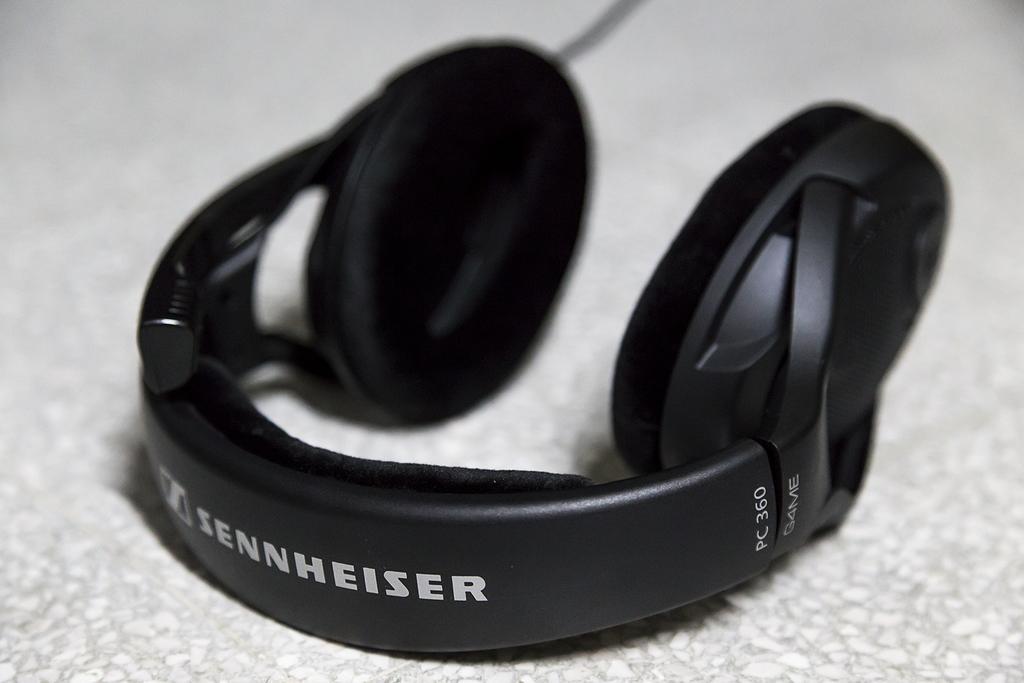Describe this image in one or two sentences. In the picture I can see a black color headphone on a white color surface. On this headphone I can see something written on it. 